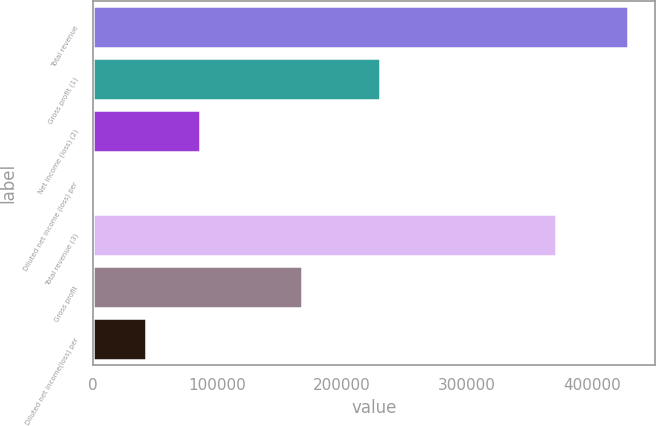<chart> <loc_0><loc_0><loc_500><loc_500><bar_chart><fcel>Total revenue<fcel>Gross profit (1)<fcel>Net income (loss) (2)<fcel>Diluted net income (loss) per<fcel>Total revenue (3)<fcel>Gross profit<fcel>Diluted net income(loss) per<nl><fcel>429233<fcel>229959<fcel>85846.8<fcel>0.19<fcel>371445<fcel>167835<fcel>42923.5<nl></chart> 